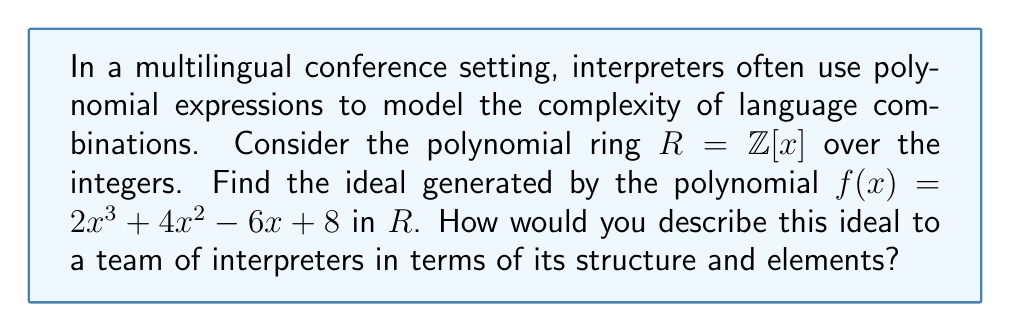Help me with this question. Let's approach this step-by-step:

1) The ideal generated by $f(x) = 2x^3 + 4x^2 - 6x + 8$ in $R = \mathbb{Z}[x]$ is denoted as $\langle f(x) \rangle$.

2) By definition, $\langle f(x) \rangle = \{r(x)f(x) : r(x) \in R\}$. This means the ideal consists of all polynomials that are multiples of $f(x)$.

3) In more detail:
   $$\langle f(x) \rangle = \{(ax^n + bx^{n-1} + ... + k)(2x^3 + 4x^2 - 6x + 8) : a,b,...,k \in \mathbb{Z}, n \geq 0\}$$

4) The structure of this ideal can be described as follows:
   - Every element in the ideal will be divisible by $f(x)$.
   - The degree of any non-zero element in the ideal will be at least 3 (the degree of $f(x)$).
   - The leading coefficient of any element will always be even (as 2 is the leading coefficient of $f(x)$).

5) To interpret this for a team of interpreters:
   - The polynomial $f(x)$ represents a base complexity model for language interpretation.
   - The ideal $\langle f(x) \rangle$ represents all possible complexity models that can be derived from this base model.
   - Each element in the ideal represents a more complex interpretation scenario built upon the base model.
   - The fact that all elements have degree at least 3 suggests that all derived scenarios maintain at least the baseline complexity.
   - The even leading coefficient implies that all derived scenarios have an even level of highest complexity.
Answer: $\langle 2x^3 + 4x^2 - 6x + 8 \rangle = \{r(x)(2x^3 + 4x^2 - 6x + 8) : r(x) \in \mathbb{Z}[x]\}$ 